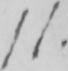Please provide the text content of this handwritten line. 11 . 